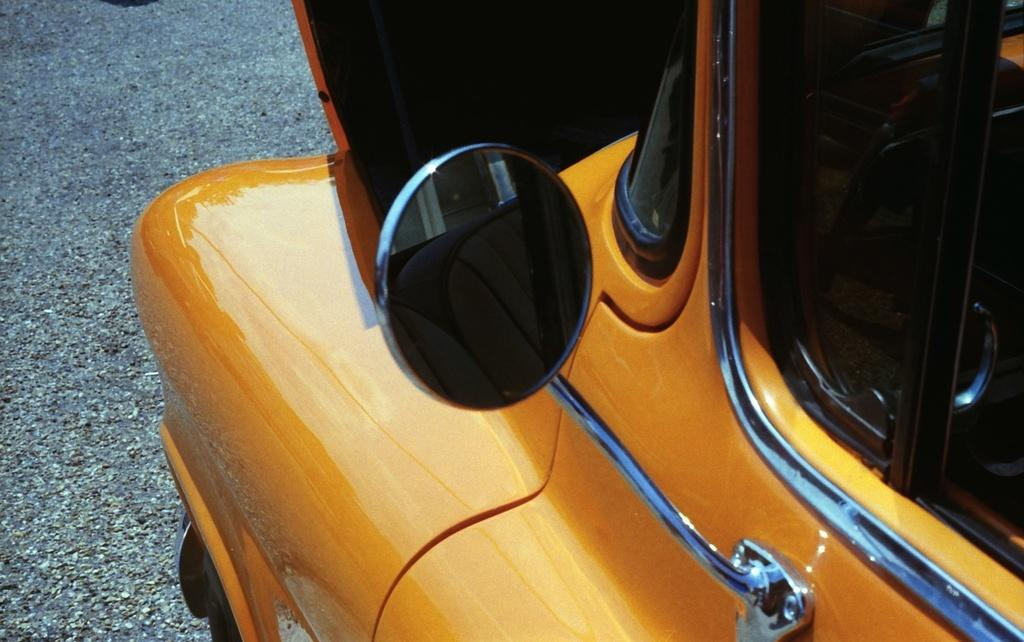What type of vehicle is shown in the image? The image is a side view of a car. What part of the car is visible on the side? There is a side mirror visible on the car. What material is used for the car windows? The car has glass windows. What else can be seen in the image besides the car? There are other objects visible in the image. What is visible on the left side of the car window? The road is visible on the left side of the window. What type of governor is present in the image? There is no governor present in the image; it is a side view of a car. What type of market can be seen in the background of the image? There is no market visible in the image; it shows a car with a side view and a road on the left side of the window. 